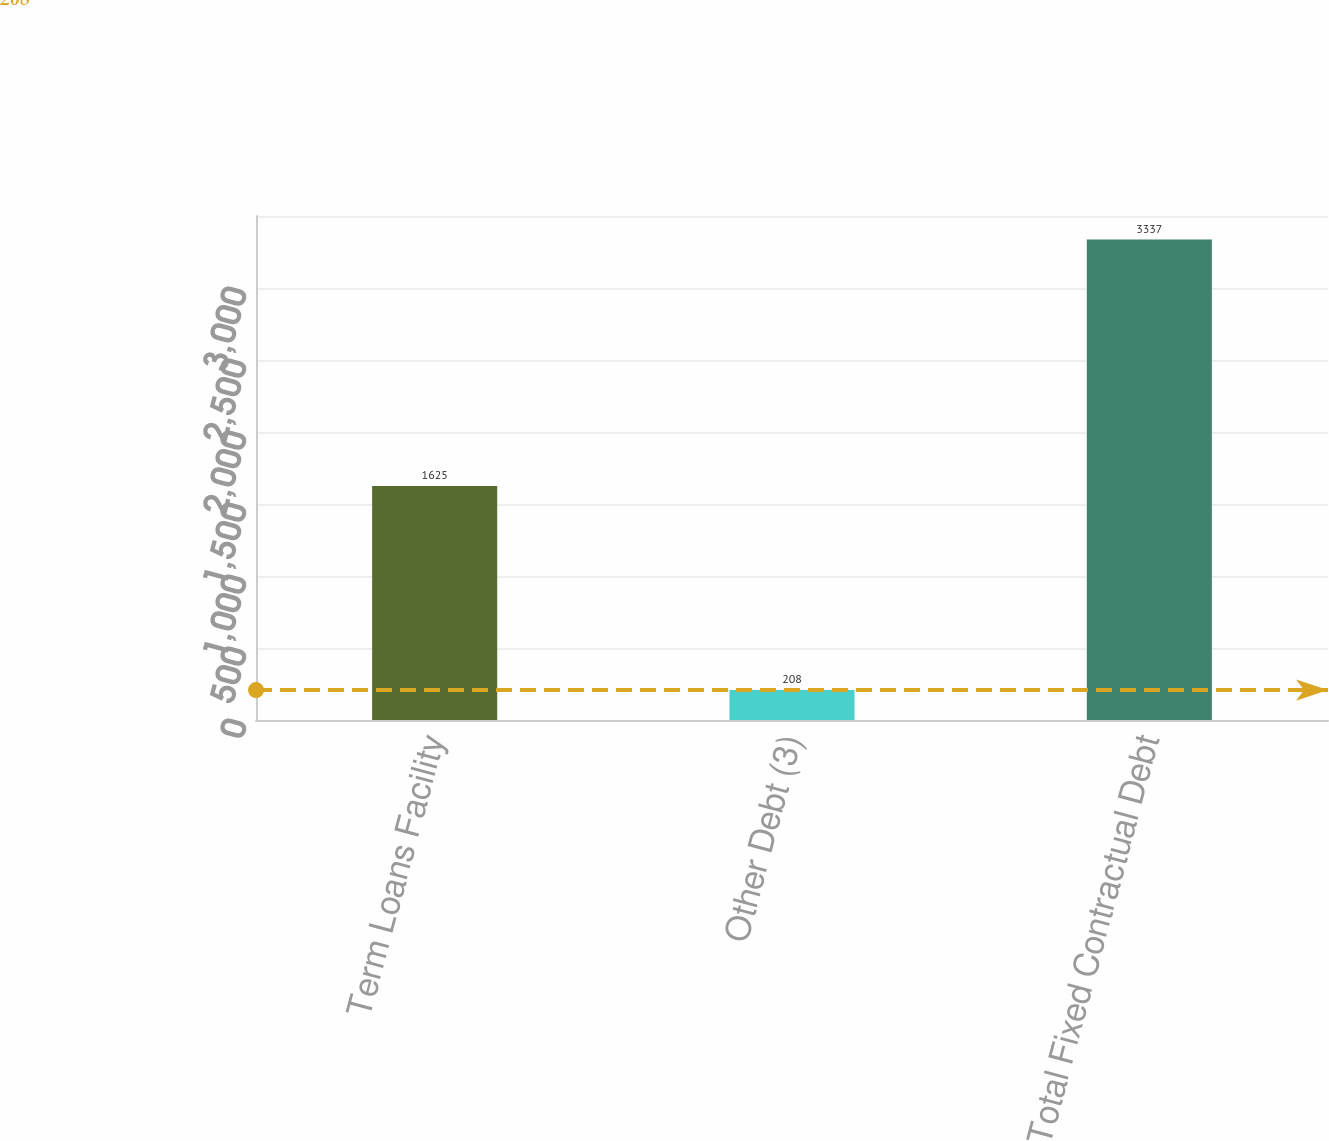Convert chart. <chart><loc_0><loc_0><loc_500><loc_500><bar_chart><fcel>Term Loans Facility<fcel>Other Debt (3)<fcel>Total Fixed Contractual Debt<nl><fcel>1625<fcel>208<fcel>3337<nl></chart> 